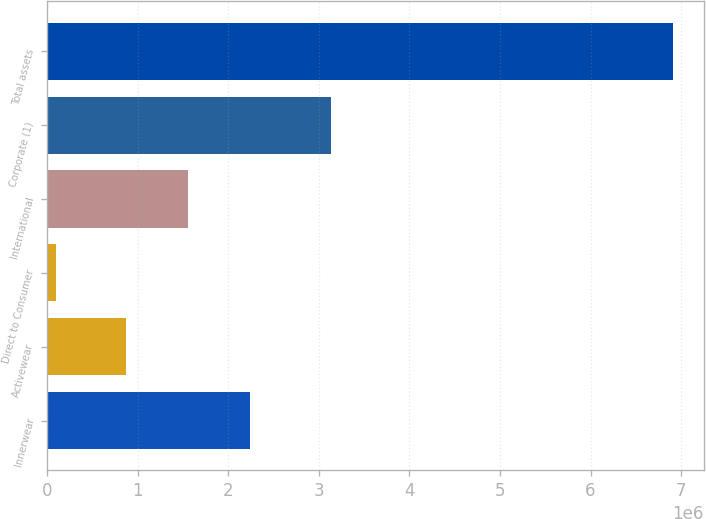<chart> <loc_0><loc_0><loc_500><loc_500><bar_chart><fcel>Innerwear<fcel>Activewear<fcel>Direct to Consumer<fcel>International<fcel>Corporate (1)<fcel>Total assets<nl><fcel>2.23678e+06<fcel>874006<fcel>93887<fcel>1.55539e+06<fcel>3.13204e+06<fcel>6.90773e+06<nl></chart> 